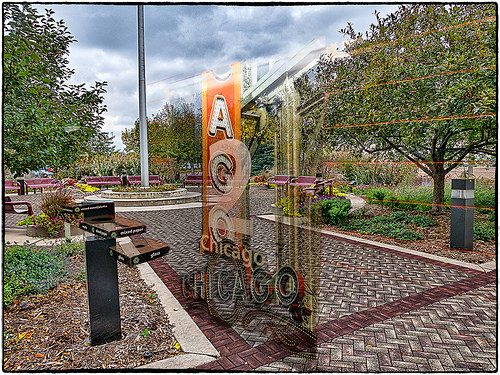<image>
Is there a pole to the left of the brick? No. The pole is not to the left of the brick. From this viewpoint, they have a different horizontal relationship. 